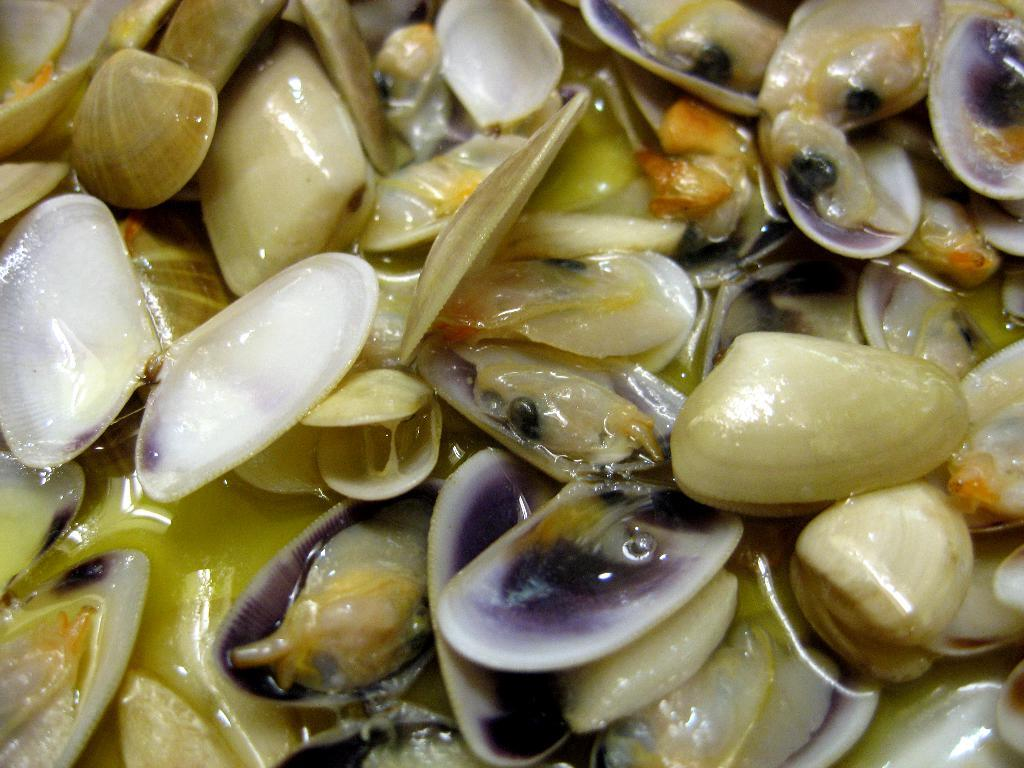What type of objects can be seen in the image? There are shells in the image. What living creatures are present in the image? There are snails in the image. What causes the cough in the image? There is no cough present in the image, as it features shells and snails. What type of mint is visible in the image? There is no mint present in the image. 